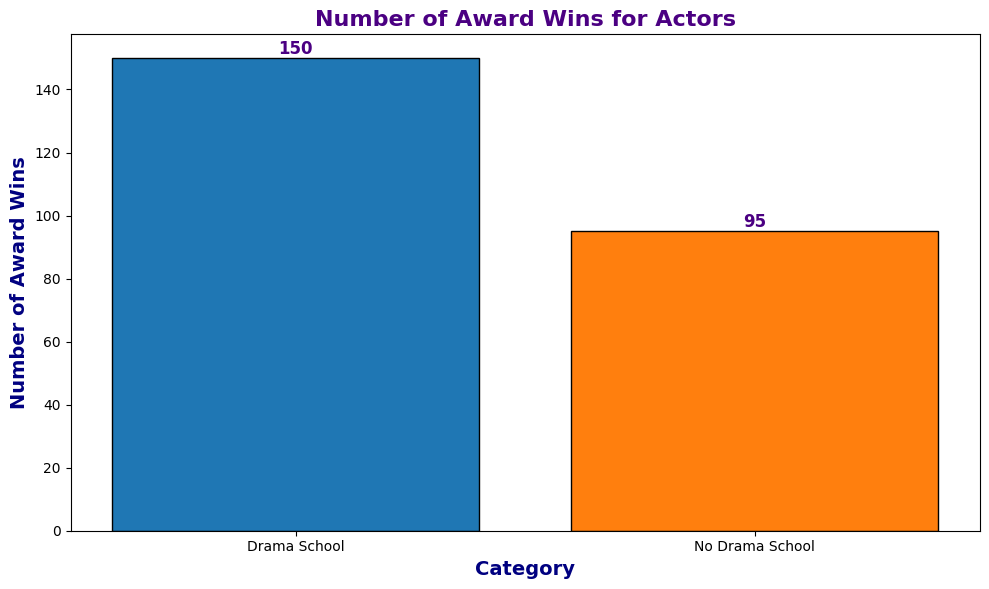what is the total number of award wins for actors in both categories combined? Sum the number of award wins for "Drama School" and "No Drama School" categories: 150 + 95 = 245
Answer: 245 Which category has a higher number of award wins? Compare the number of award wins for "Drama School" (150) and "No Drama School" (95). 150 is greater than 95
Answer: Drama School By how much does the number of award wins for actors who attended drama school exceed those who did not? Subtract the number of award wins for "No Drama School" from "Drama School": 150 - 95 = 55
Answer: 55 What's the percentage of award wins for actors who attended drama school out of the total number of award wins? Calculate the total number of award wins: 150 (Drama School) + 95 (No Drama School) = 245. Then, find the percentage: (150 / 245) * 100 ≈ 61.22%
Answer: 61.22% What is the height difference between the two bars in the chart? The "Drama School" bar height is 150, and the "No Drama School" bar height is 95. The difference is 150 - 95 = 55
Answer: 55 Which category's bar is colored blue? Identify the color used for each category's bar: "Drama School" is blue and "No Drama School" is orange
Answer: Drama School If the number of award wins for "No Drama School" doubled, would it exceed the number of award wins for "Drama School"? Doubling the number of award wins for "No Drama School": 95 * 2 = 190. Compare 190 with 150; 190 is greater than 150
Answer: Yes What's the ratio of award wins for actors who attended drama school to those who did not? Use the number of award wins for "Drama School" (150) and "No Drama School" (95) to form the ratio: 150:95, which simplifies to 30:19
Answer: 30:19 Which category is more represented in terms of the number of award wins? Compare the bars for "Drama School" and "No Drama School" visually and numerically; "Drama School" has more wins (150 compared to 95)
Answer: Drama School If you average the number of award wins across both categories, what would that number be? Calculate the total number of award wins: 150 + 95 = 245. Divide by the number of categories (2): 245 / 2 = 122.5
Answer: 122.5 